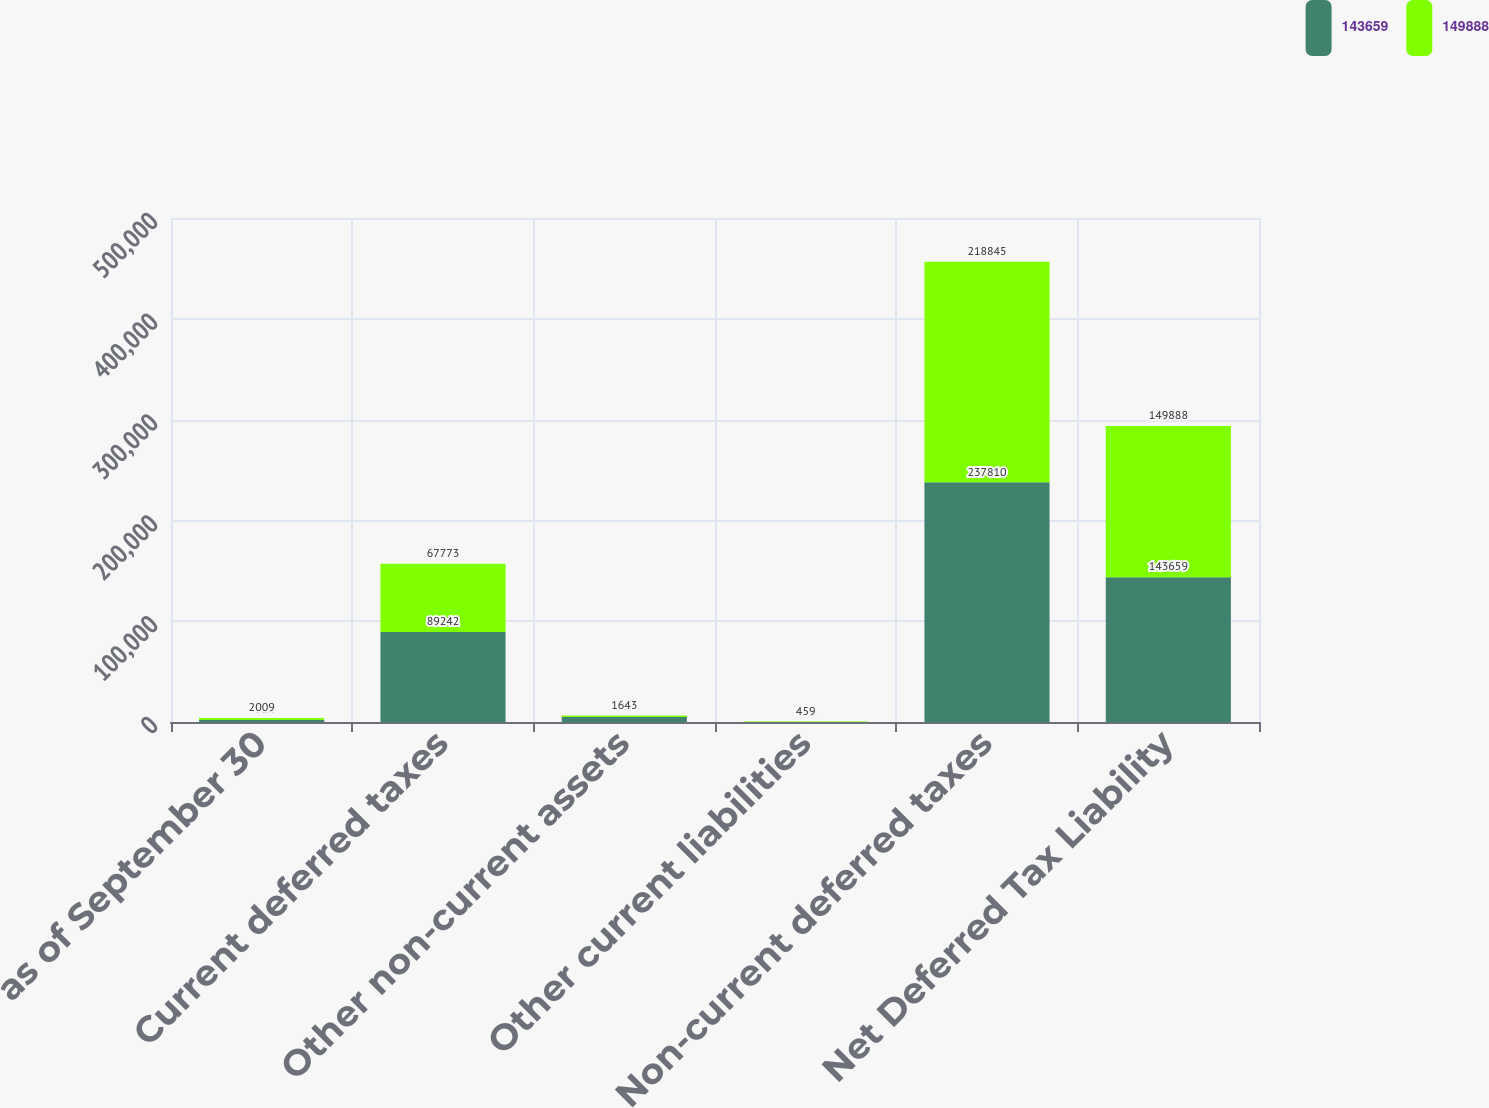<chart> <loc_0><loc_0><loc_500><loc_500><stacked_bar_chart><ecel><fcel>as of September 30<fcel>Current deferred taxes<fcel>Other non-current assets<fcel>Other current liabilities<fcel>Non-current deferred taxes<fcel>Net Deferred Tax Liability<nl><fcel>143659<fcel>2010<fcel>89242<fcel>4909<fcel>0<fcel>237810<fcel>143659<nl><fcel>149888<fcel>2009<fcel>67773<fcel>1643<fcel>459<fcel>218845<fcel>149888<nl></chart> 